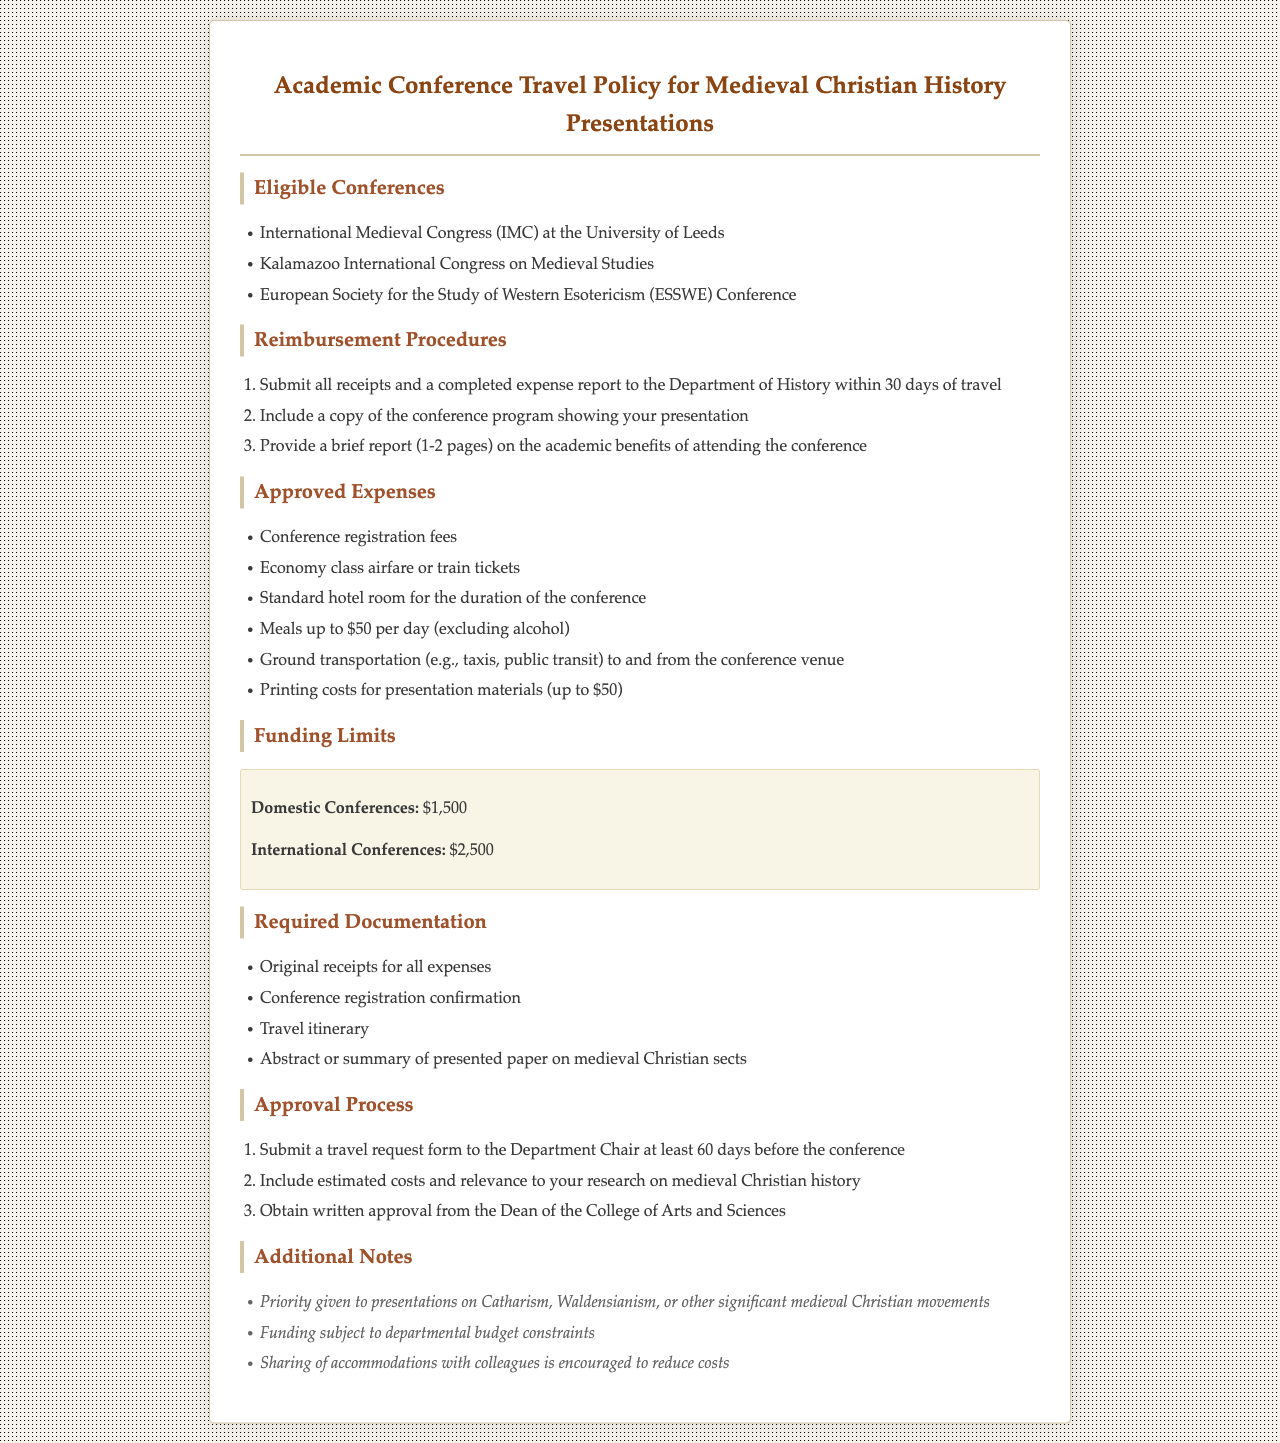What are the eligible conferences listed? The eligible conferences are specifically mentioned in the document under the "Eligible Conferences" section, including the International Medieval Congress, the Kalamazoo International Congress on Medieval Studies, and the ESSWE Conference.
Answer: International Medieval Congress, Kalamazoo International Congress on Medieval Studies, ESSWE Conference What is the maximum reimbursement for a domestic conference? The document states the funding limit for domestic conferences in the "Funding Limits" section, which is explicitly noted.
Answer: $1,500 What required documentation must be submitted? The document lists the required documentation under the "Required Documentation" section, detailing items like original receipts and conference registration confirmation.
Answer: Original receipts for all expenses, conference registration confirmation, travel itinerary, abstract or summary of presented paper on medieval Christian sects What is the reimbursement timeframe after travel? The "Reimbursement Procedures" section outlines that all receipts and a completed expense report should be submitted within a set timeframe after the travel.
Answer: 30 days What type of expenses are approved? The approved expenses are detailed in the document in the "Approved Expenses" section, identifying acceptable costs incurred during conference attendance.
Answer: Conference registration fees, economy class airfare or train tickets, standard hotel room for the duration of the conference, meals up to $50 per day, ground transportation, printing costs for presentation materials What is a requirement for the travel request submission? The document specifies that a travel request form needs to be submitted at least 60 days before the conference, which is highlighted in the "Approval Process" section.
Answer: 60 days What is a focus area for priority funding? The document indicates that priority funding is given to certain topics in the "Additional Notes" section, guiding applicants on favored areas for presentations.
Answer: Catharism, Waldensianism, or other significant medieval Christian movements What is the required length of the report on conference benefits? The document stipulates the length of the report to be submitted as part of the reimbursement procedures, reflecting the academic benefits of attending.
Answer: 1-2 pages 